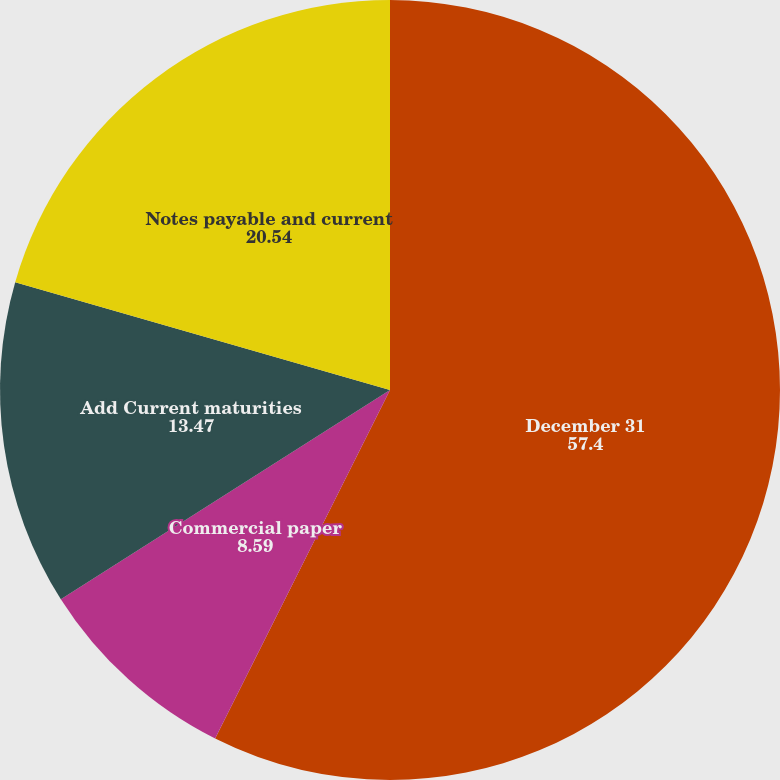Convert chart. <chart><loc_0><loc_0><loc_500><loc_500><pie_chart><fcel>December 31<fcel>Commercial paper<fcel>Add Current maturities<fcel>Notes payable and current<nl><fcel>57.4%<fcel>8.59%<fcel>13.47%<fcel>20.54%<nl></chart> 